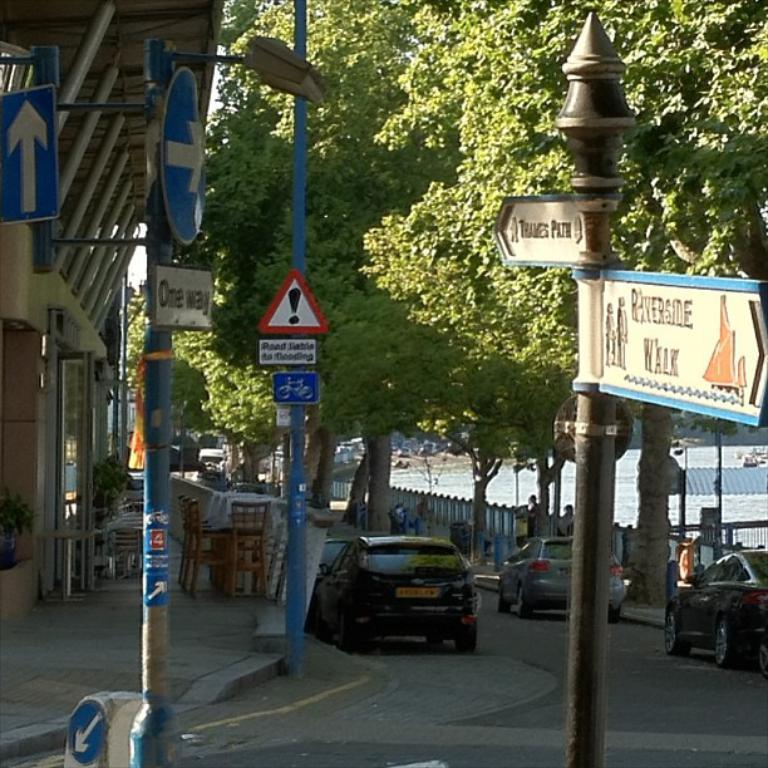What type of vehicles are present in the image? There are cars in the image. What can be seen beside the cars in the image? There are trees beside the cars in the image. What architectural feature is visible in the image? There is a railing in the image. Where is the table located in the image? There is no table present in the image. What type of furniture is visible in the image? There is no furniture visible in the image; only cars, trees, and a railing are present. 